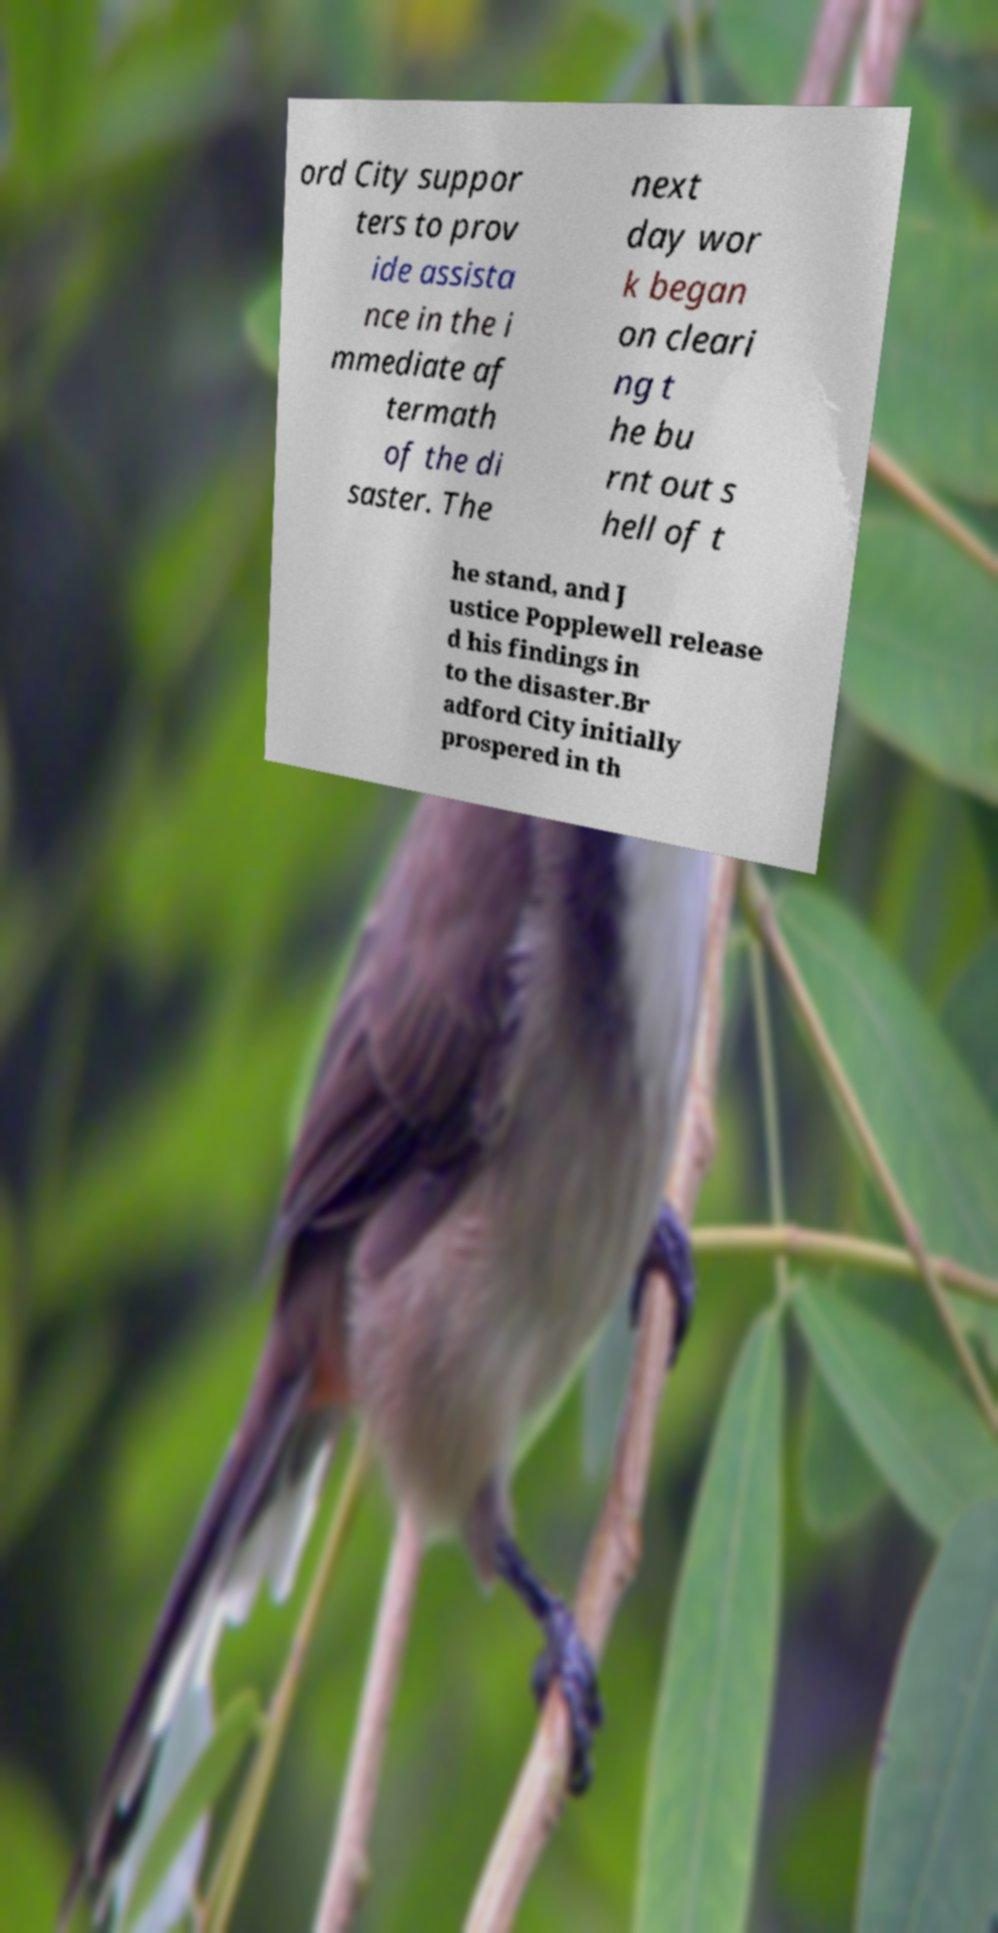Please read and relay the text visible in this image. What does it say? ord City suppor ters to prov ide assista nce in the i mmediate af termath of the di saster. The next day wor k began on cleari ng t he bu rnt out s hell of t he stand, and J ustice Popplewell release d his findings in to the disaster.Br adford City initially prospered in th 